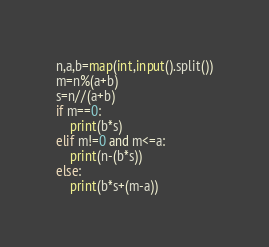Convert code to text. <code><loc_0><loc_0><loc_500><loc_500><_Python_>n,a,b=map(int,input().split())
m=n%(a+b)
s=n//(a+b)
if m==0:
    print(b*s)
elif m!=0 and m<=a:
    print(n-(b*s))
else:
    print(b*s+(m-a))</code> 